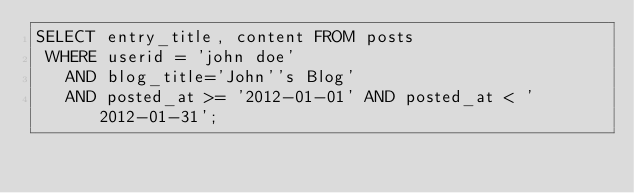<code> <loc_0><loc_0><loc_500><loc_500><_SQL_>SELECT entry_title, content FROM posts
 WHERE userid = 'john doe'
   AND blog_title='John''s Blog'
   AND posted_at >= '2012-01-01' AND posted_at < '2012-01-31';
</code> 